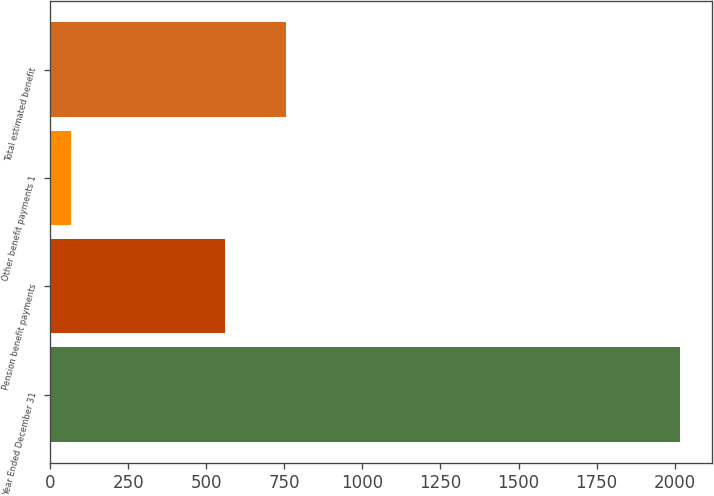Convert chart to OTSL. <chart><loc_0><loc_0><loc_500><loc_500><bar_chart><fcel>Year Ended December 31<fcel>Pension benefit payments<fcel>Other benefit payments 1<fcel>Total estimated benefit<nl><fcel>2018<fcel>560<fcel>67<fcel>755.1<nl></chart> 